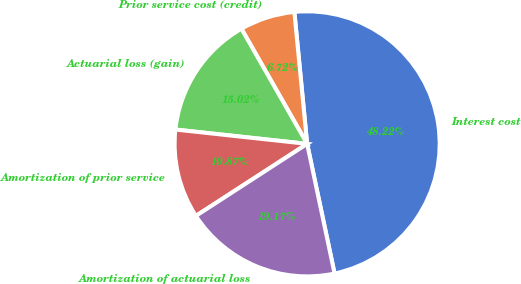Convert chart to OTSL. <chart><loc_0><loc_0><loc_500><loc_500><pie_chart><fcel>Interest cost<fcel>Prior service cost (credit)<fcel>Actuarial loss (gain)<fcel>Amortization of prior service<fcel>Amortization of actuarial loss<nl><fcel>48.22%<fcel>6.72%<fcel>15.02%<fcel>10.87%<fcel>19.17%<nl></chart> 